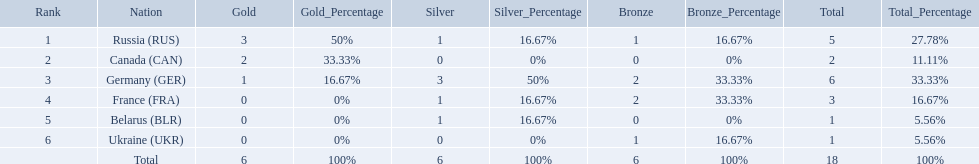Which nations participated? Russia (RUS), Canada (CAN), Germany (GER), France (FRA), Belarus (BLR), Ukraine (UKR). And how many gold medals did they win? 3, 2, 1, 0, 0, 0. What about silver medals? 1, 0, 3, 1, 1, 0. And bronze? 1, 0, 2, 2, 0, 1. Which nation only won gold medals? Canada (CAN). Which countries had one or more gold medals? Russia (RUS), Canada (CAN), Germany (GER). Of these countries, which had at least one silver medal? Russia (RUS), Germany (GER). Of the remaining countries, who had more medals overall? Germany (GER). What were all the countries that won biathlon medals? Russia (RUS), Canada (CAN), Germany (GER), France (FRA), Belarus (BLR), Ukraine (UKR). What were their medal counts? 5, 2, 6, 3, 1, 1. Of these, which is the largest number of medals? 6. Which country won this number of medals? Germany (GER). 